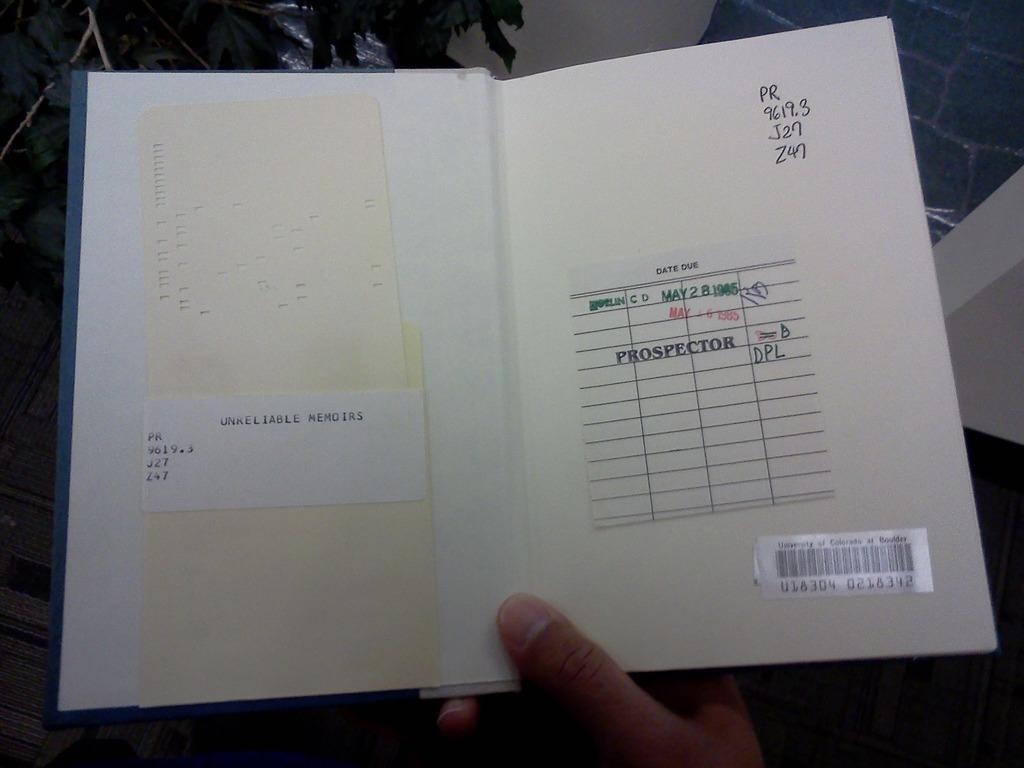<image>
Summarize the visual content of the image. A book belonging to a library goes by the title Unreliable Memoirs. 